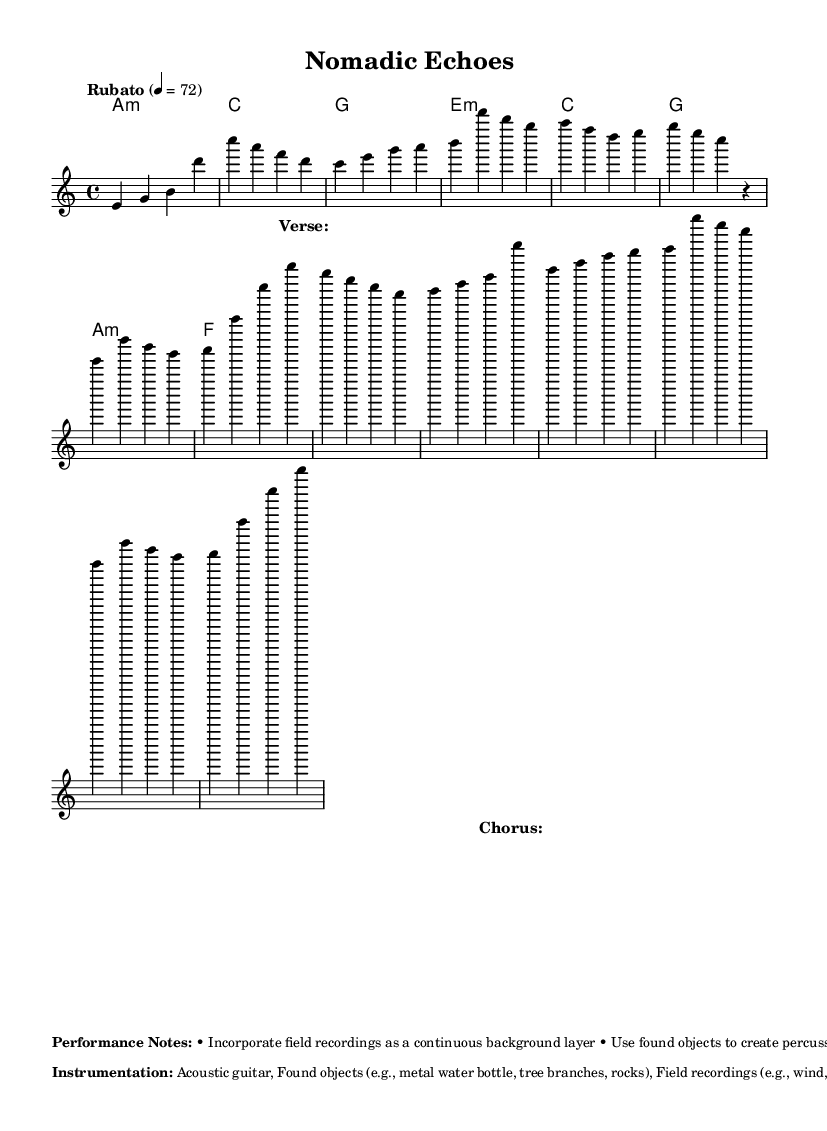What is the time signature of this music? The time signature is indicated at the beginning of the score, shown as 4/4, meaning there are four beats per measure and the quarter note gets one beat.
Answer: 4/4 What is the tempo marking for this piece? The tempo marking is found in the global section of the music, indicated as "Rubato" with a metronome marking of 72 beats per minute. This means that the performer can take liberties with the timing while maintaining an overall pace of 72 beats per minute.
Answer: Rubato, 72 How many verses are included in this composition? By analyzing the structure indicated in the score, there are two verses: "Verse 1" and "Verse 2" (abbreviated).
Answer: Two What type of sounds are encouraged to be used for percussion? The performance notes specify the use of "found objects" to create percussive sounds, which suggests incorporating everyday items found during travels such as metal water bottles and tree branches.
Answer: Found objects What unique aspect differentiates this music as experimental? The continuous incorporation of "field recordings" as a background layer alongside the traditional instrumentation distinguishes it as experimental, allowing for interaction with natural sounds like wind and bird calls.
Answer: Field recordings What is the primary instrument featured in the score? The main instrument highlighted in both the score and the instrumentation section is the "Acoustic guitar," which drives the composition's melody and harmonics.
Answer: Acoustic guitar 